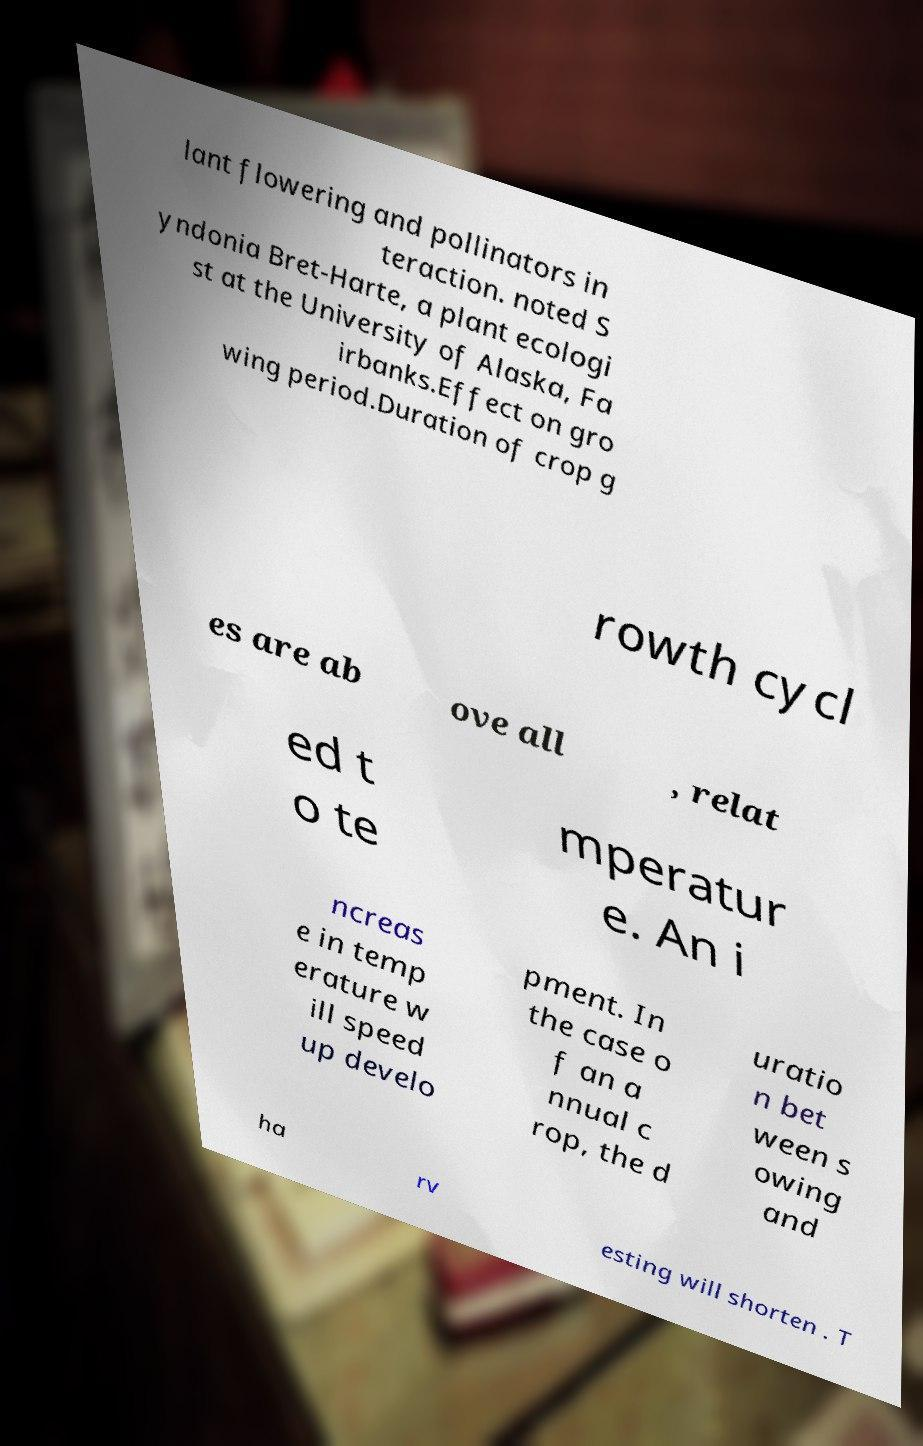Could you assist in decoding the text presented in this image and type it out clearly? lant flowering and pollinators in teraction. noted S yndonia Bret-Harte, a plant ecologi st at the University of Alaska, Fa irbanks.Effect on gro wing period.Duration of crop g rowth cycl es are ab ove all , relat ed t o te mperatur e. An i ncreas e in temp erature w ill speed up develo pment. In the case o f an a nnual c rop, the d uratio n bet ween s owing and ha rv esting will shorten . T 